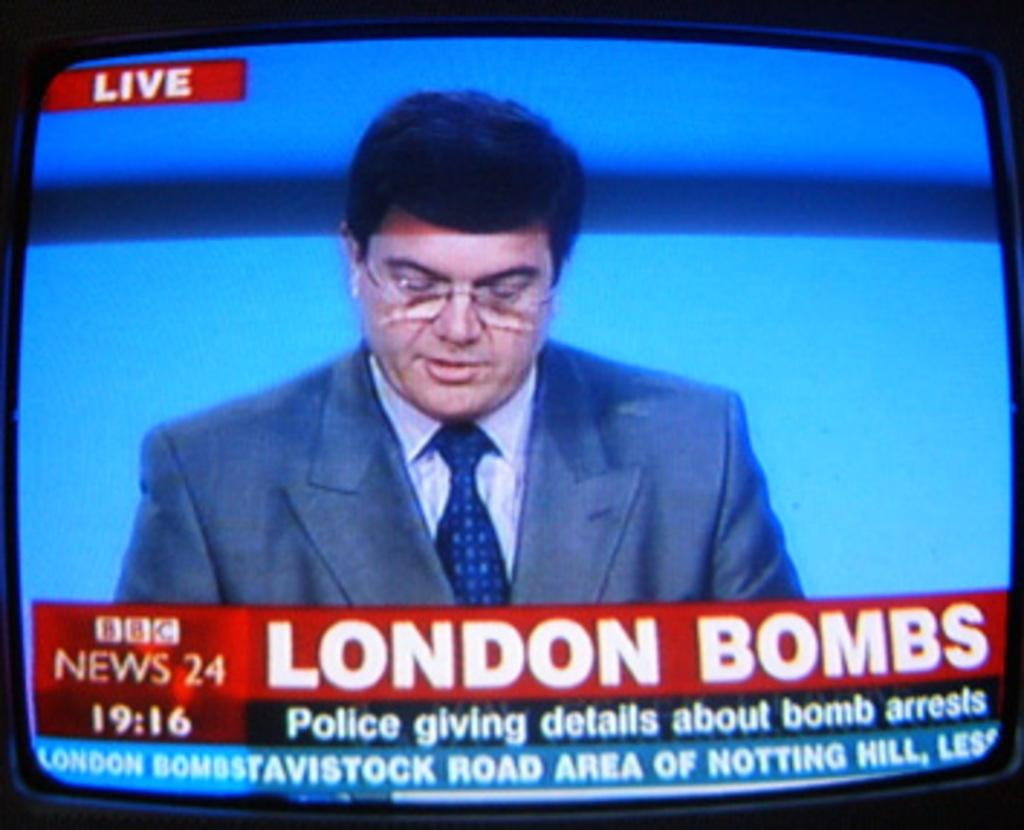What is the main object in the image? There is a screen in the image. What can be seen on the screen? A man is visible on the screen, and there is text on the screen as well. Where is the flower located in the image? There is no flower present in the image. What type of corn is being sold at the store in the image? There is no store or corn present in the image. 